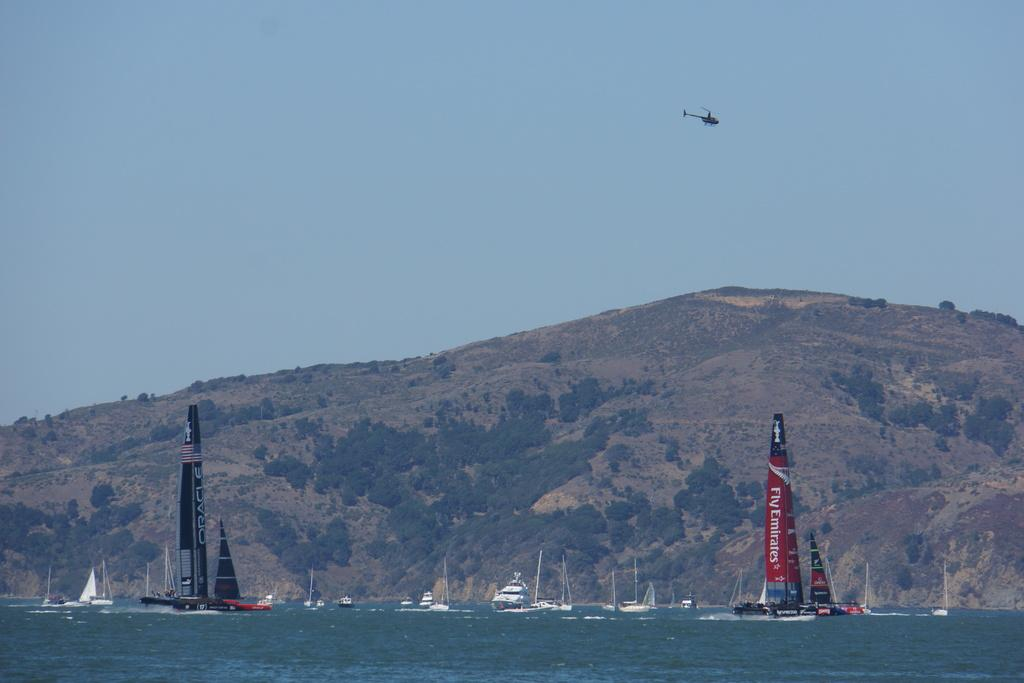<image>
Provide a brief description of the given image. A sailboat with a sail that says to fly Emirates on it is in the water with other boats. 